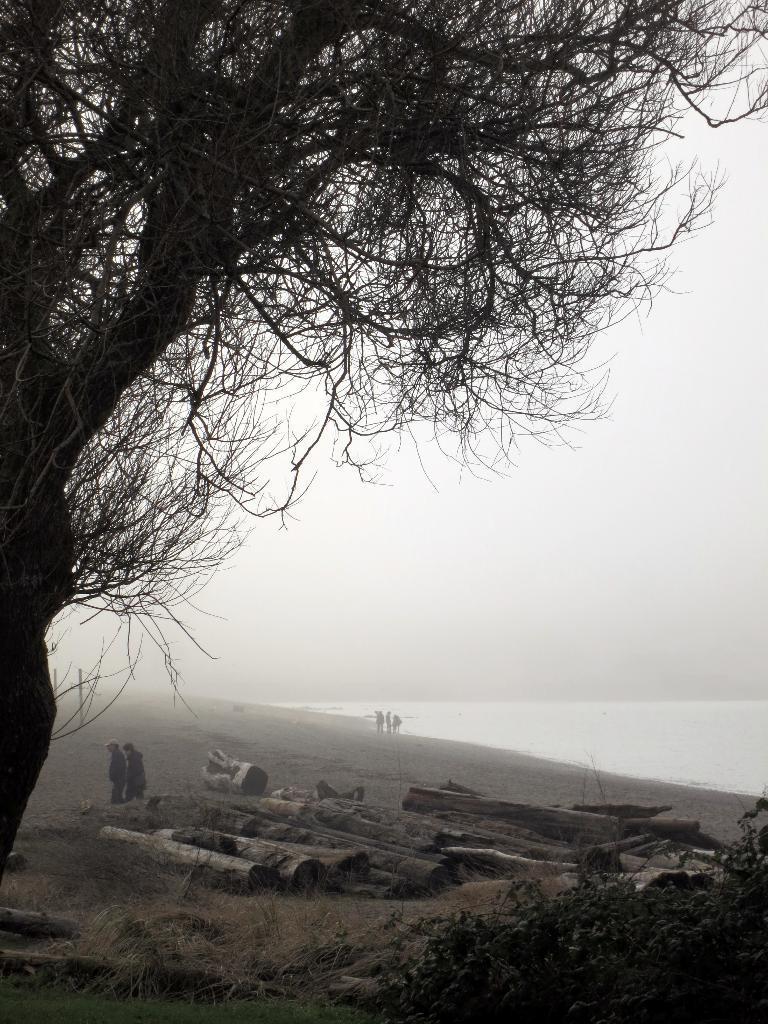How would you summarize this image in a sentence or two? As we can see in the image there is a tree, few people here and there and there is water. 